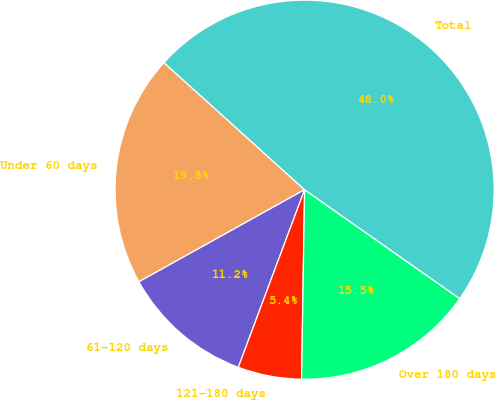Convert chart to OTSL. <chart><loc_0><loc_0><loc_500><loc_500><pie_chart><fcel>Under 60 days<fcel>61-120 days<fcel>121-180 days<fcel>Over 180 days<fcel>Total<nl><fcel>19.77%<fcel>11.24%<fcel>5.43%<fcel>15.51%<fcel>48.05%<nl></chart> 